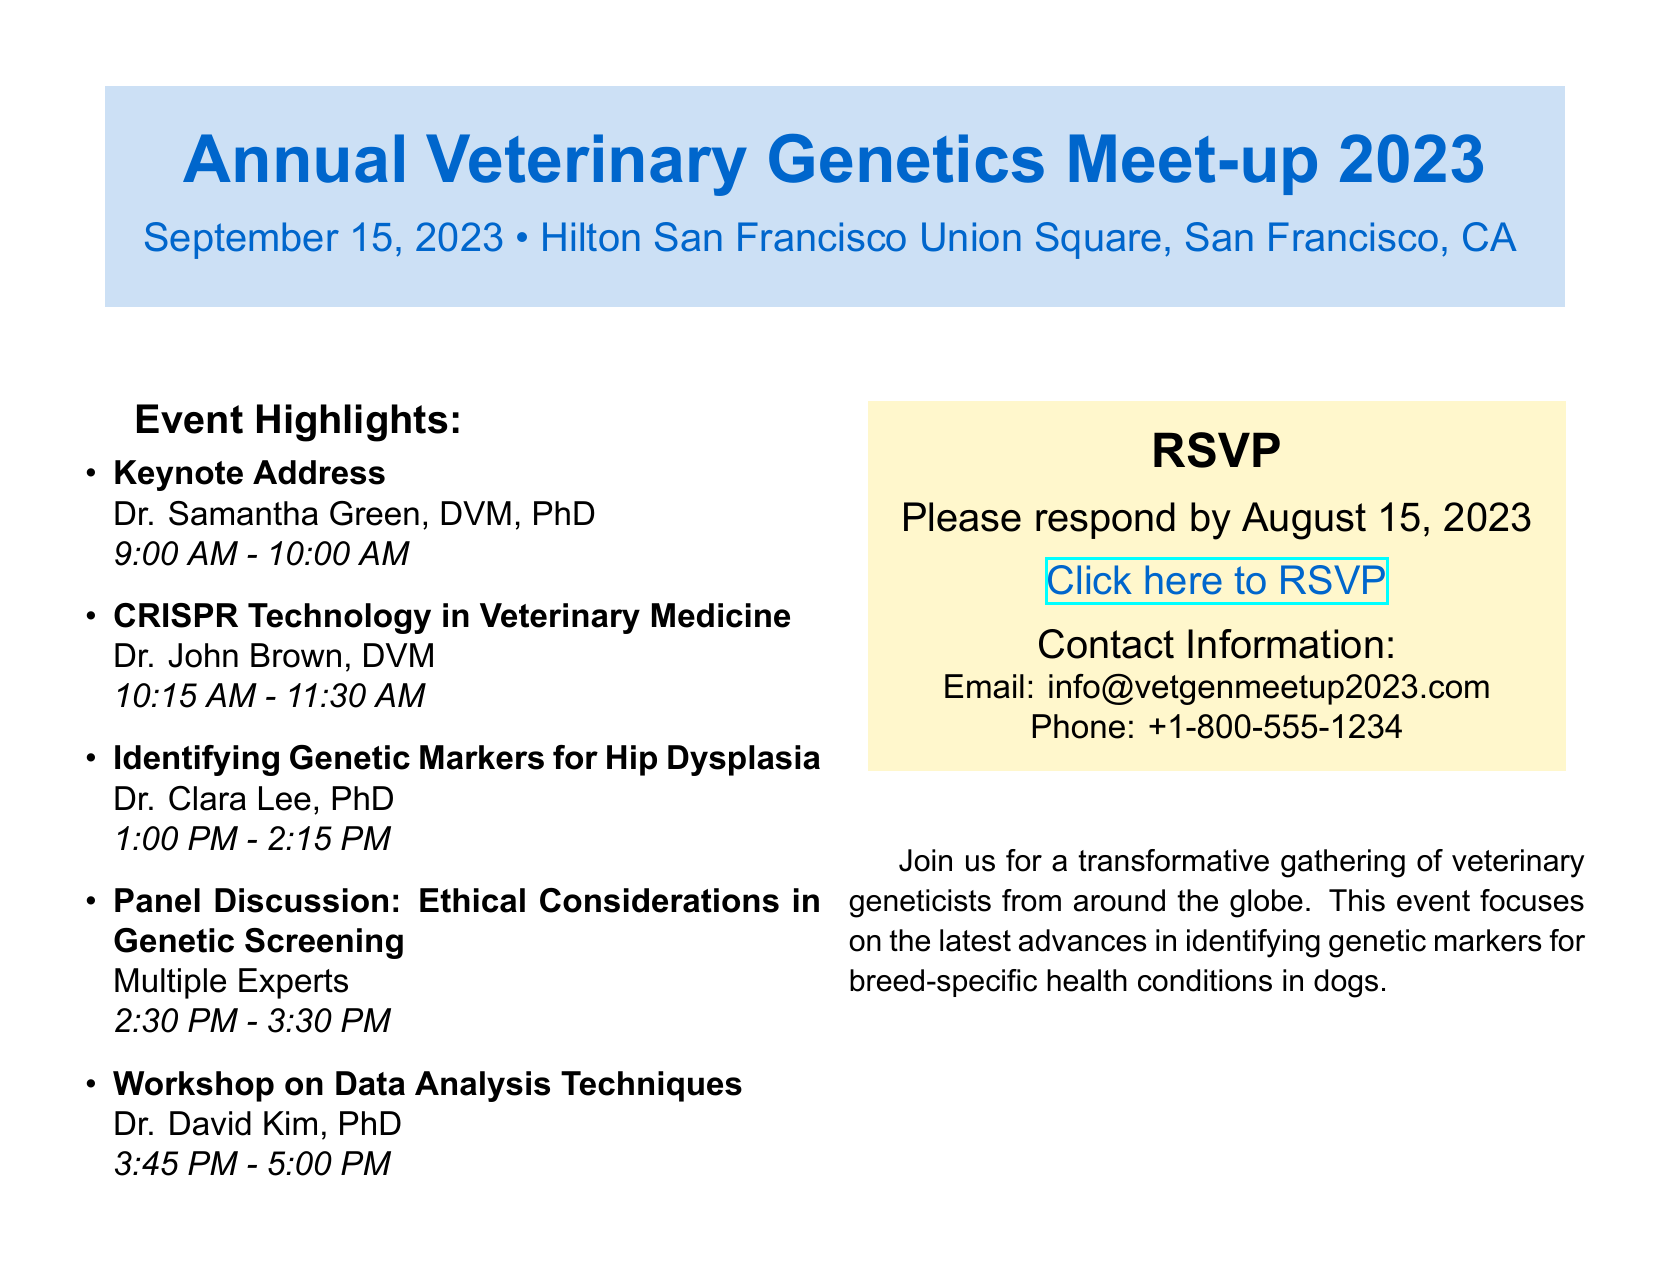What is the date of the event? The event is scheduled for September 15, 2023, as indicated at the top of the document.
Answer: September 15, 2023 Who is giving the keynote address? The keynote address is delivered by Dr. Samantha Green, as mentioned in the Event Highlights section.
Answer: Dr. Samantha Green What time does the workshop on data analysis techniques start? The start time can be found in the schedule of workshops; it is shown as 3:45 PM.
Answer: 3:45 PM What is the deadline for RSVP? The RSVP deadline is specified as August 15, 2023, in the RSVP section.
Answer: August 15, 2023 What major topic does the event focus on? The focus of the event is stated in the closing remarks; it centers on identifying genetic markers for breed-specific health conditions in dogs.
Answer: Genetic markers for breed-specific health conditions in dogs How many workshops are listed in the document? The number of workshops can be counted in the Event Highlights section, and there are five listed workshops.
Answer: Five 